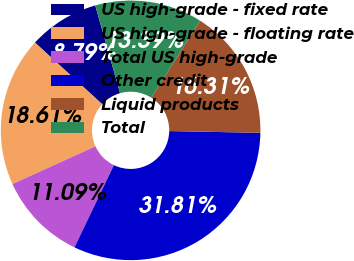<chart> <loc_0><loc_0><loc_500><loc_500><pie_chart><fcel>US high-grade - fixed rate<fcel>US high-grade - floating rate<fcel>Total US high-grade<fcel>Other credit<fcel>Liquid products<fcel>Total<nl><fcel>8.79%<fcel>18.61%<fcel>11.09%<fcel>31.81%<fcel>16.31%<fcel>13.39%<nl></chart> 